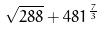Convert formula to latex. <formula><loc_0><loc_0><loc_500><loc_500>\sqrt { 2 8 8 } + 4 8 1 ^ { \frac { 7 } { 3 } }</formula> 